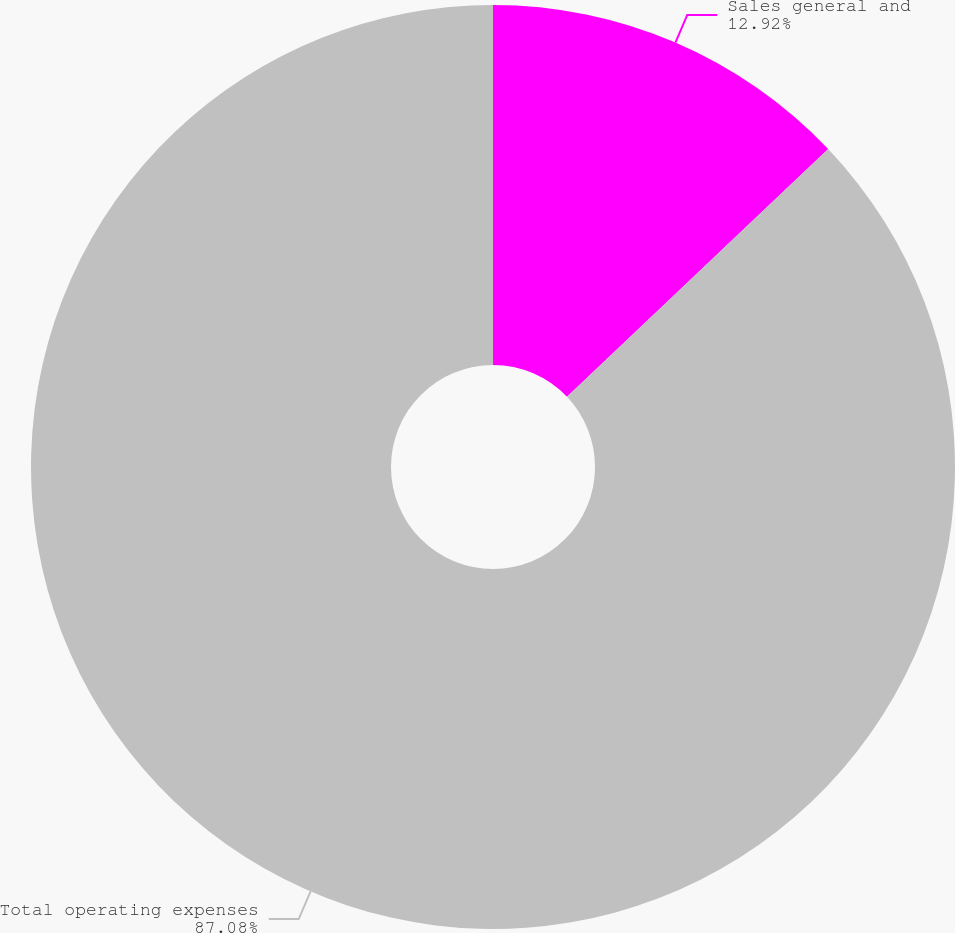Convert chart to OTSL. <chart><loc_0><loc_0><loc_500><loc_500><pie_chart><fcel>Sales general and<fcel>Total operating expenses<nl><fcel>12.92%<fcel>87.08%<nl></chart> 